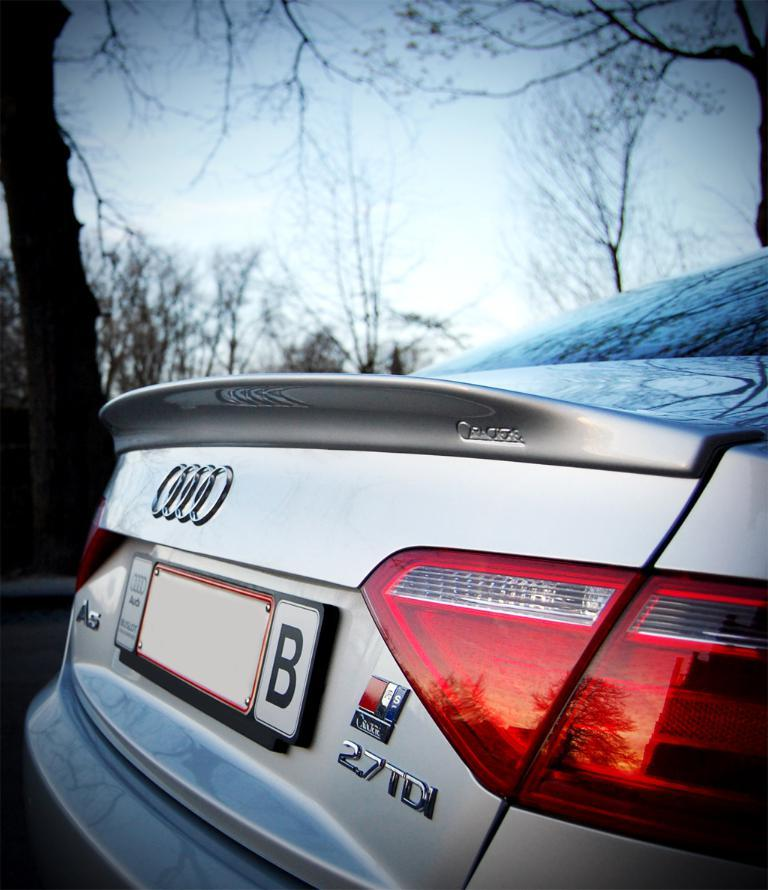<image>
Relay a brief, clear account of the picture shown. The trunk of an Audi 2.7 TDI is shown on a street. 